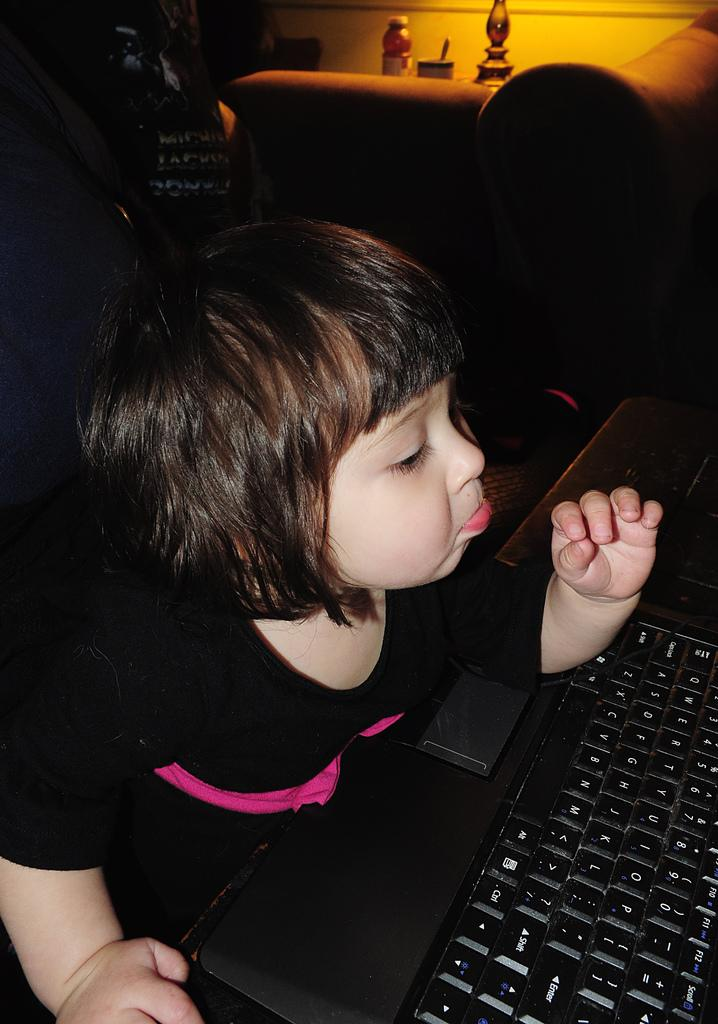Who is the main subject in the image? There is a girl in the image. What object is visible next to the girl? There is a keyboard in the image. Can you describe what is visible behind the girl in the image? There are some objects visible behind the girl in the image. What type of whistle can be heard in the image? There is no whistle present in the image, and therefore no sound can be heard. What is the girl's tendency towards playing the keyboard in the image? The image does not provide information about the girl's tendency towards playing the keyboard. 